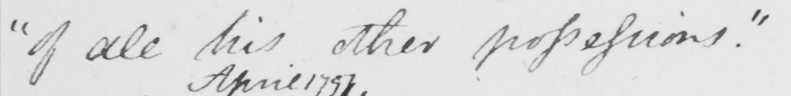What is written in this line of handwriting? " of all his other possessions . " 